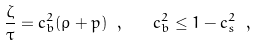<formula> <loc_0><loc_0><loc_500><loc_500>\frac { \zeta } { \tau } = c _ { b } ^ { 2 } ( \rho + p ) \ , \quad c _ { b } ^ { 2 } \leq 1 - c _ { s } ^ { 2 } \ ,</formula> 